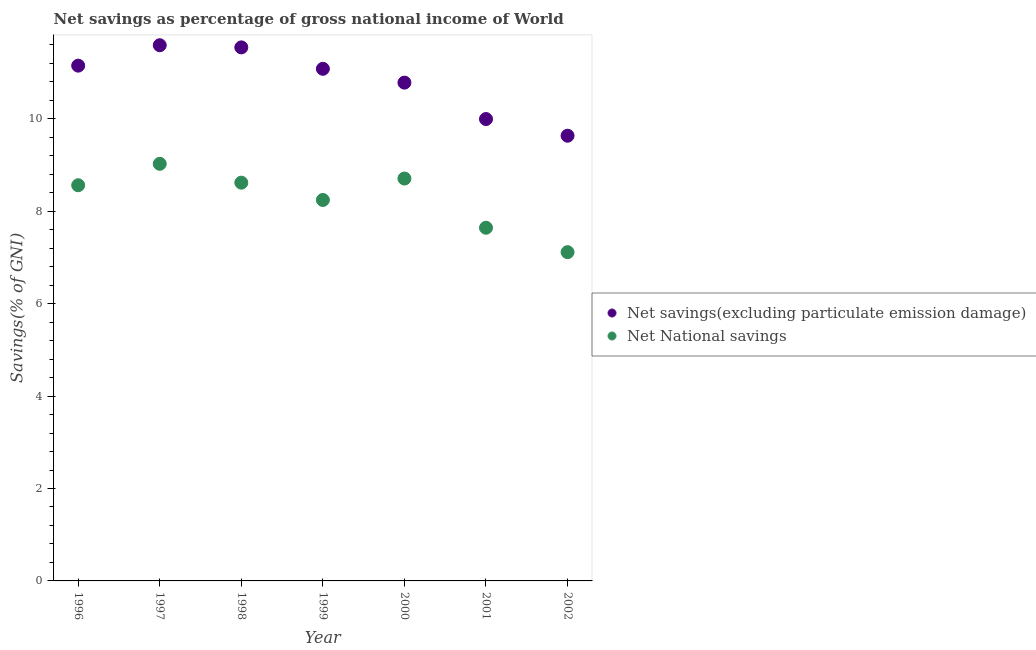How many different coloured dotlines are there?
Make the answer very short. 2. What is the net national savings in 2002?
Your response must be concise. 7.11. Across all years, what is the maximum net national savings?
Make the answer very short. 9.03. Across all years, what is the minimum net savings(excluding particulate emission damage)?
Keep it short and to the point. 9.63. What is the total net savings(excluding particulate emission damage) in the graph?
Your answer should be compact. 75.78. What is the difference between the net national savings in 1998 and that in 2000?
Your answer should be very brief. -0.09. What is the difference between the net national savings in 1999 and the net savings(excluding particulate emission damage) in 2000?
Offer a terse response. -2.54. What is the average net national savings per year?
Provide a succinct answer. 8.27. In the year 2000, what is the difference between the net national savings and net savings(excluding particulate emission damage)?
Your answer should be compact. -2.08. What is the ratio of the net savings(excluding particulate emission damage) in 2000 to that in 2002?
Ensure brevity in your answer.  1.12. Is the difference between the net savings(excluding particulate emission damage) in 1997 and 1998 greater than the difference between the net national savings in 1997 and 1998?
Your answer should be very brief. No. What is the difference between the highest and the second highest net national savings?
Keep it short and to the point. 0.32. What is the difference between the highest and the lowest net savings(excluding particulate emission damage)?
Your answer should be very brief. 1.96. Is the net savings(excluding particulate emission damage) strictly less than the net national savings over the years?
Offer a terse response. No. How many dotlines are there?
Provide a short and direct response. 2. How many years are there in the graph?
Provide a short and direct response. 7. How many legend labels are there?
Provide a succinct answer. 2. What is the title of the graph?
Offer a terse response. Net savings as percentage of gross national income of World. What is the label or title of the Y-axis?
Your response must be concise. Savings(% of GNI). What is the Savings(% of GNI) of Net savings(excluding particulate emission damage) in 1996?
Your answer should be compact. 11.15. What is the Savings(% of GNI) in Net National savings in 1996?
Provide a short and direct response. 8.56. What is the Savings(% of GNI) of Net savings(excluding particulate emission damage) in 1997?
Your answer should be very brief. 11.59. What is the Savings(% of GNI) of Net National savings in 1997?
Keep it short and to the point. 9.03. What is the Savings(% of GNI) in Net savings(excluding particulate emission damage) in 1998?
Offer a very short reply. 11.55. What is the Savings(% of GNI) in Net National savings in 1998?
Provide a short and direct response. 8.62. What is the Savings(% of GNI) of Net savings(excluding particulate emission damage) in 1999?
Make the answer very short. 11.08. What is the Savings(% of GNI) in Net National savings in 1999?
Offer a terse response. 8.24. What is the Savings(% of GNI) in Net savings(excluding particulate emission damage) in 2000?
Your answer should be compact. 10.78. What is the Savings(% of GNI) of Net National savings in 2000?
Offer a very short reply. 8.71. What is the Savings(% of GNI) in Net savings(excluding particulate emission damage) in 2001?
Keep it short and to the point. 9.99. What is the Savings(% of GNI) in Net National savings in 2001?
Give a very brief answer. 7.64. What is the Savings(% of GNI) of Net savings(excluding particulate emission damage) in 2002?
Make the answer very short. 9.63. What is the Savings(% of GNI) of Net National savings in 2002?
Keep it short and to the point. 7.11. Across all years, what is the maximum Savings(% of GNI) in Net savings(excluding particulate emission damage)?
Your answer should be compact. 11.59. Across all years, what is the maximum Savings(% of GNI) in Net National savings?
Provide a succinct answer. 9.03. Across all years, what is the minimum Savings(% of GNI) in Net savings(excluding particulate emission damage)?
Provide a short and direct response. 9.63. Across all years, what is the minimum Savings(% of GNI) of Net National savings?
Your answer should be compact. 7.11. What is the total Savings(% of GNI) in Net savings(excluding particulate emission damage) in the graph?
Your response must be concise. 75.78. What is the total Savings(% of GNI) of Net National savings in the graph?
Ensure brevity in your answer.  57.91. What is the difference between the Savings(% of GNI) of Net savings(excluding particulate emission damage) in 1996 and that in 1997?
Provide a succinct answer. -0.44. What is the difference between the Savings(% of GNI) in Net National savings in 1996 and that in 1997?
Ensure brevity in your answer.  -0.46. What is the difference between the Savings(% of GNI) of Net savings(excluding particulate emission damage) in 1996 and that in 1998?
Offer a terse response. -0.4. What is the difference between the Savings(% of GNI) of Net National savings in 1996 and that in 1998?
Make the answer very short. -0.06. What is the difference between the Savings(% of GNI) in Net savings(excluding particulate emission damage) in 1996 and that in 1999?
Make the answer very short. 0.07. What is the difference between the Savings(% of GNI) in Net National savings in 1996 and that in 1999?
Offer a very short reply. 0.32. What is the difference between the Savings(% of GNI) of Net savings(excluding particulate emission damage) in 1996 and that in 2000?
Make the answer very short. 0.37. What is the difference between the Savings(% of GNI) in Net National savings in 1996 and that in 2000?
Offer a very short reply. -0.15. What is the difference between the Savings(% of GNI) of Net savings(excluding particulate emission damage) in 1996 and that in 2001?
Your answer should be very brief. 1.16. What is the difference between the Savings(% of GNI) of Net National savings in 1996 and that in 2001?
Your response must be concise. 0.92. What is the difference between the Savings(% of GNI) of Net savings(excluding particulate emission damage) in 1996 and that in 2002?
Make the answer very short. 1.52. What is the difference between the Savings(% of GNI) of Net National savings in 1996 and that in 2002?
Your response must be concise. 1.45. What is the difference between the Savings(% of GNI) of Net savings(excluding particulate emission damage) in 1997 and that in 1998?
Provide a succinct answer. 0.05. What is the difference between the Savings(% of GNI) in Net National savings in 1997 and that in 1998?
Offer a very short reply. 0.41. What is the difference between the Savings(% of GNI) in Net savings(excluding particulate emission damage) in 1997 and that in 1999?
Keep it short and to the point. 0.51. What is the difference between the Savings(% of GNI) of Net National savings in 1997 and that in 1999?
Make the answer very short. 0.78. What is the difference between the Savings(% of GNI) of Net savings(excluding particulate emission damage) in 1997 and that in 2000?
Your response must be concise. 0.81. What is the difference between the Savings(% of GNI) of Net National savings in 1997 and that in 2000?
Your response must be concise. 0.32. What is the difference between the Savings(% of GNI) of Net savings(excluding particulate emission damage) in 1997 and that in 2001?
Your answer should be compact. 1.6. What is the difference between the Savings(% of GNI) of Net National savings in 1997 and that in 2001?
Your response must be concise. 1.38. What is the difference between the Savings(% of GNI) in Net savings(excluding particulate emission damage) in 1997 and that in 2002?
Your answer should be very brief. 1.96. What is the difference between the Savings(% of GNI) of Net National savings in 1997 and that in 2002?
Ensure brevity in your answer.  1.91. What is the difference between the Savings(% of GNI) of Net savings(excluding particulate emission damage) in 1998 and that in 1999?
Give a very brief answer. 0.46. What is the difference between the Savings(% of GNI) in Net National savings in 1998 and that in 1999?
Provide a succinct answer. 0.37. What is the difference between the Savings(% of GNI) of Net savings(excluding particulate emission damage) in 1998 and that in 2000?
Your answer should be very brief. 0.76. What is the difference between the Savings(% of GNI) of Net National savings in 1998 and that in 2000?
Your answer should be very brief. -0.09. What is the difference between the Savings(% of GNI) in Net savings(excluding particulate emission damage) in 1998 and that in 2001?
Make the answer very short. 1.55. What is the difference between the Savings(% of GNI) of Net National savings in 1998 and that in 2001?
Your answer should be very brief. 0.98. What is the difference between the Savings(% of GNI) in Net savings(excluding particulate emission damage) in 1998 and that in 2002?
Make the answer very short. 1.91. What is the difference between the Savings(% of GNI) of Net National savings in 1998 and that in 2002?
Your answer should be compact. 1.5. What is the difference between the Savings(% of GNI) in Net savings(excluding particulate emission damage) in 1999 and that in 2000?
Your response must be concise. 0.3. What is the difference between the Savings(% of GNI) in Net National savings in 1999 and that in 2000?
Provide a succinct answer. -0.46. What is the difference between the Savings(% of GNI) of Net savings(excluding particulate emission damage) in 1999 and that in 2001?
Offer a terse response. 1.09. What is the difference between the Savings(% of GNI) of Net National savings in 1999 and that in 2001?
Give a very brief answer. 0.6. What is the difference between the Savings(% of GNI) of Net savings(excluding particulate emission damage) in 1999 and that in 2002?
Keep it short and to the point. 1.45. What is the difference between the Savings(% of GNI) of Net National savings in 1999 and that in 2002?
Provide a succinct answer. 1.13. What is the difference between the Savings(% of GNI) of Net savings(excluding particulate emission damage) in 2000 and that in 2001?
Your answer should be very brief. 0.79. What is the difference between the Savings(% of GNI) in Net National savings in 2000 and that in 2001?
Keep it short and to the point. 1.06. What is the difference between the Savings(% of GNI) of Net savings(excluding particulate emission damage) in 2000 and that in 2002?
Your answer should be compact. 1.15. What is the difference between the Savings(% of GNI) of Net National savings in 2000 and that in 2002?
Your response must be concise. 1.59. What is the difference between the Savings(% of GNI) of Net savings(excluding particulate emission damage) in 2001 and that in 2002?
Ensure brevity in your answer.  0.36. What is the difference between the Savings(% of GNI) in Net National savings in 2001 and that in 2002?
Your answer should be compact. 0.53. What is the difference between the Savings(% of GNI) in Net savings(excluding particulate emission damage) in 1996 and the Savings(% of GNI) in Net National savings in 1997?
Your response must be concise. 2.12. What is the difference between the Savings(% of GNI) in Net savings(excluding particulate emission damage) in 1996 and the Savings(% of GNI) in Net National savings in 1998?
Your answer should be very brief. 2.53. What is the difference between the Savings(% of GNI) of Net savings(excluding particulate emission damage) in 1996 and the Savings(% of GNI) of Net National savings in 1999?
Your answer should be very brief. 2.91. What is the difference between the Savings(% of GNI) of Net savings(excluding particulate emission damage) in 1996 and the Savings(% of GNI) of Net National savings in 2000?
Your answer should be very brief. 2.44. What is the difference between the Savings(% of GNI) in Net savings(excluding particulate emission damage) in 1996 and the Savings(% of GNI) in Net National savings in 2001?
Provide a succinct answer. 3.51. What is the difference between the Savings(% of GNI) in Net savings(excluding particulate emission damage) in 1996 and the Savings(% of GNI) in Net National savings in 2002?
Your response must be concise. 4.04. What is the difference between the Savings(% of GNI) in Net savings(excluding particulate emission damage) in 1997 and the Savings(% of GNI) in Net National savings in 1998?
Offer a terse response. 2.97. What is the difference between the Savings(% of GNI) of Net savings(excluding particulate emission damage) in 1997 and the Savings(% of GNI) of Net National savings in 1999?
Ensure brevity in your answer.  3.35. What is the difference between the Savings(% of GNI) of Net savings(excluding particulate emission damage) in 1997 and the Savings(% of GNI) of Net National savings in 2000?
Ensure brevity in your answer.  2.88. What is the difference between the Savings(% of GNI) in Net savings(excluding particulate emission damage) in 1997 and the Savings(% of GNI) in Net National savings in 2001?
Your answer should be compact. 3.95. What is the difference between the Savings(% of GNI) of Net savings(excluding particulate emission damage) in 1997 and the Savings(% of GNI) of Net National savings in 2002?
Make the answer very short. 4.48. What is the difference between the Savings(% of GNI) of Net savings(excluding particulate emission damage) in 1998 and the Savings(% of GNI) of Net National savings in 1999?
Your answer should be compact. 3.3. What is the difference between the Savings(% of GNI) in Net savings(excluding particulate emission damage) in 1998 and the Savings(% of GNI) in Net National savings in 2000?
Offer a terse response. 2.84. What is the difference between the Savings(% of GNI) in Net savings(excluding particulate emission damage) in 1998 and the Savings(% of GNI) in Net National savings in 2001?
Keep it short and to the point. 3.9. What is the difference between the Savings(% of GNI) of Net savings(excluding particulate emission damage) in 1998 and the Savings(% of GNI) of Net National savings in 2002?
Offer a very short reply. 4.43. What is the difference between the Savings(% of GNI) of Net savings(excluding particulate emission damage) in 1999 and the Savings(% of GNI) of Net National savings in 2000?
Your response must be concise. 2.37. What is the difference between the Savings(% of GNI) of Net savings(excluding particulate emission damage) in 1999 and the Savings(% of GNI) of Net National savings in 2001?
Your response must be concise. 3.44. What is the difference between the Savings(% of GNI) of Net savings(excluding particulate emission damage) in 1999 and the Savings(% of GNI) of Net National savings in 2002?
Offer a terse response. 3.97. What is the difference between the Savings(% of GNI) in Net savings(excluding particulate emission damage) in 2000 and the Savings(% of GNI) in Net National savings in 2001?
Make the answer very short. 3.14. What is the difference between the Savings(% of GNI) in Net savings(excluding particulate emission damage) in 2000 and the Savings(% of GNI) in Net National savings in 2002?
Give a very brief answer. 3.67. What is the difference between the Savings(% of GNI) in Net savings(excluding particulate emission damage) in 2001 and the Savings(% of GNI) in Net National savings in 2002?
Give a very brief answer. 2.88. What is the average Savings(% of GNI) of Net savings(excluding particulate emission damage) per year?
Keep it short and to the point. 10.83. What is the average Savings(% of GNI) in Net National savings per year?
Offer a terse response. 8.27. In the year 1996, what is the difference between the Savings(% of GNI) in Net savings(excluding particulate emission damage) and Savings(% of GNI) in Net National savings?
Give a very brief answer. 2.59. In the year 1997, what is the difference between the Savings(% of GNI) in Net savings(excluding particulate emission damage) and Savings(% of GNI) in Net National savings?
Give a very brief answer. 2.57. In the year 1998, what is the difference between the Savings(% of GNI) of Net savings(excluding particulate emission damage) and Savings(% of GNI) of Net National savings?
Keep it short and to the point. 2.93. In the year 1999, what is the difference between the Savings(% of GNI) in Net savings(excluding particulate emission damage) and Savings(% of GNI) in Net National savings?
Keep it short and to the point. 2.84. In the year 2000, what is the difference between the Savings(% of GNI) of Net savings(excluding particulate emission damage) and Savings(% of GNI) of Net National savings?
Keep it short and to the point. 2.08. In the year 2001, what is the difference between the Savings(% of GNI) of Net savings(excluding particulate emission damage) and Savings(% of GNI) of Net National savings?
Ensure brevity in your answer.  2.35. In the year 2002, what is the difference between the Savings(% of GNI) of Net savings(excluding particulate emission damage) and Savings(% of GNI) of Net National savings?
Your answer should be very brief. 2.52. What is the ratio of the Savings(% of GNI) in Net savings(excluding particulate emission damage) in 1996 to that in 1997?
Your answer should be very brief. 0.96. What is the ratio of the Savings(% of GNI) in Net National savings in 1996 to that in 1997?
Keep it short and to the point. 0.95. What is the ratio of the Savings(% of GNI) in Net savings(excluding particulate emission damage) in 1996 to that in 1998?
Provide a succinct answer. 0.97. What is the ratio of the Savings(% of GNI) in Net savings(excluding particulate emission damage) in 1996 to that in 1999?
Provide a short and direct response. 1.01. What is the ratio of the Savings(% of GNI) of Net National savings in 1996 to that in 1999?
Offer a terse response. 1.04. What is the ratio of the Savings(% of GNI) in Net savings(excluding particulate emission damage) in 1996 to that in 2000?
Give a very brief answer. 1.03. What is the ratio of the Savings(% of GNI) in Net National savings in 1996 to that in 2000?
Your answer should be very brief. 0.98. What is the ratio of the Savings(% of GNI) of Net savings(excluding particulate emission damage) in 1996 to that in 2001?
Keep it short and to the point. 1.12. What is the ratio of the Savings(% of GNI) in Net National savings in 1996 to that in 2001?
Your answer should be very brief. 1.12. What is the ratio of the Savings(% of GNI) of Net savings(excluding particulate emission damage) in 1996 to that in 2002?
Your answer should be very brief. 1.16. What is the ratio of the Savings(% of GNI) in Net National savings in 1996 to that in 2002?
Ensure brevity in your answer.  1.2. What is the ratio of the Savings(% of GNI) in Net savings(excluding particulate emission damage) in 1997 to that in 1998?
Provide a succinct answer. 1. What is the ratio of the Savings(% of GNI) in Net National savings in 1997 to that in 1998?
Make the answer very short. 1.05. What is the ratio of the Savings(% of GNI) of Net savings(excluding particulate emission damage) in 1997 to that in 1999?
Keep it short and to the point. 1.05. What is the ratio of the Savings(% of GNI) of Net National savings in 1997 to that in 1999?
Your response must be concise. 1.09. What is the ratio of the Savings(% of GNI) in Net savings(excluding particulate emission damage) in 1997 to that in 2000?
Keep it short and to the point. 1.08. What is the ratio of the Savings(% of GNI) of Net National savings in 1997 to that in 2000?
Keep it short and to the point. 1.04. What is the ratio of the Savings(% of GNI) of Net savings(excluding particulate emission damage) in 1997 to that in 2001?
Your answer should be compact. 1.16. What is the ratio of the Savings(% of GNI) in Net National savings in 1997 to that in 2001?
Provide a short and direct response. 1.18. What is the ratio of the Savings(% of GNI) in Net savings(excluding particulate emission damage) in 1997 to that in 2002?
Offer a terse response. 1.2. What is the ratio of the Savings(% of GNI) of Net National savings in 1997 to that in 2002?
Your answer should be compact. 1.27. What is the ratio of the Savings(% of GNI) of Net savings(excluding particulate emission damage) in 1998 to that in 1999?
Offer a terse response. 1.04. What is the ratio of the Savings(% of GNI) in Net National savings in 1998 to that in 1999?
Provide a succinct answer. 1.05. What is the ratio of the Savings(% of GNI) of Net savings(excluding particulate emission damage) in 1998 to that in 2000?
Provide a succinct answer. 1.07. What is the ratio of the Savings(% of GNI) in Net National savings in 1998 to that in 2000?
Make the answer very short. 0.99. What is the ratio of the Savings(% of GNI) of Net savings(excluding particulate emission damage) in 1998 to that in 2001?
Provide a succinct answer. 1.16. What is the ratio of the Savings(% of GNI) in Net National savings in 1998 to that in 2001?
Give a very brief answer. 1.13. What is the ratio of the Savings(% of GNI) of Net savings(excluding particulate emission damage) in 1998 to that in 2002?
Give a very brief answer. 1.2. What is the ratio of the Savings(% of GNI) in Net National savings in 1998 to that in 2002?
Offer a very short reply. 1.21. What is the ratio of the Savings(% of GNI) of Net savings(excluding particulate emission damage) in 1999 to that in 2000?
Ensure brevity in your answer.  1.03. What is the ratio of the Savings(% of GNI) in Net National savings in 1999 to that in 2000?
Provide a short and direct response. 0.95. What is the ratio of the Savings(% of GNI) in Net savings(excluding particulate emission damage) in 1999 to that in 2001?
Ensure brevity in your answer.  1.11. What is the ratio of the Savings(% of GNI) in Net National savings in 1999 to that in 2001?
Your response must be concise. 1.08. What is the ratio of the Savings(% of GNI) in Net savings(excluding particulate emission damage) in 1999 to that in 2002?
Your response must be concise. 1.15. What is the ratio of the Savings(% of GNI) in Net National savings in 1999 to that in 2002?
Provide a succinct answer. 1.16. What is the ratio of the Savings(% of GNI) in Net savings(excluding particulate emission damage) in 2000 to that in 2001?
Offer a very short reply. 1.08. What is the ratio of the Savings(% of GNI) in Net National savings in 2000 to that in 2001?
Ensure brevity in your answer.  1.14. What is the ratio of the Savings(% of GNI) in Net savings(excluding particulate emission damage) in 2000 to that in 2002?
Your response must be concise. 1.12. What is the ratio of the Savings(% of GNI) of Net National savings in 2000 to that in 2002?
Offer a terse response. 1.22. What is the ratio of the Savings(% of GNI) in Net savings(excluding particulate emission damage) in 2001 to that in 2002?
Provide a succinct answer. 1.04. What is the ratio of the Savings(% of GNI) of Net National savings in 2001 to that in 2002?
Your response must be concise. 1.07. What is the difference between the highest and the second highest Savings(% of GNI) of Net savings(excluding particulate emission damage)?
Your answer should be compact. 0.05. What is the difference between the highest and the second highest Savings(% of GNI) of Net National savings?
Your answer should be compact. 0.32. What is the difference between the highest and the lowest Savings(% of GNI) in Net savings(excluding particulate emission damage)?
Make the answer very short. 1.96. What is the difference between the highest and the lowest Savings(% of GNI) of Net National savings?
Provide a short and direct response. 1.91. 